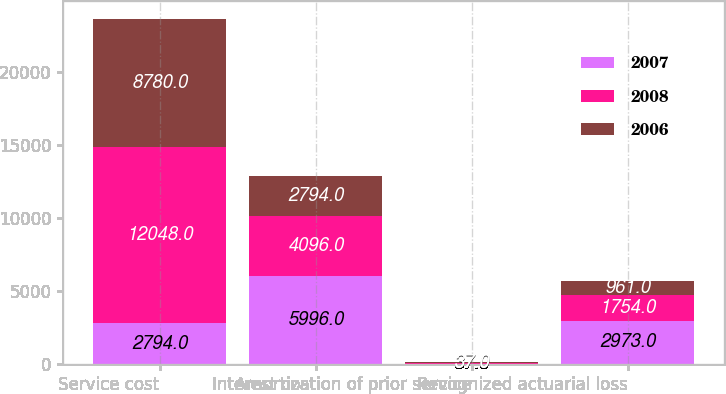Convert chart to OTSL. <chart><loc_0><loc_0><loc_500><loc_500><stacked_bar_chart><ecel><fcel>Service cost<fcel>Interest cost<fcel>Amortization of prior service<fcel>Recognized actuarial loss<nl><fcel>2007<fcel>2794<fcel>5996<fcel>37<fcel>2973<nl><fcel>2008<fcel>12048<fcel>4096<fcel>37<fcel>1754<nl><fcel>2006<fcel>8780<fcel>2794<fcel>37<fcel>961<nl></chart> 